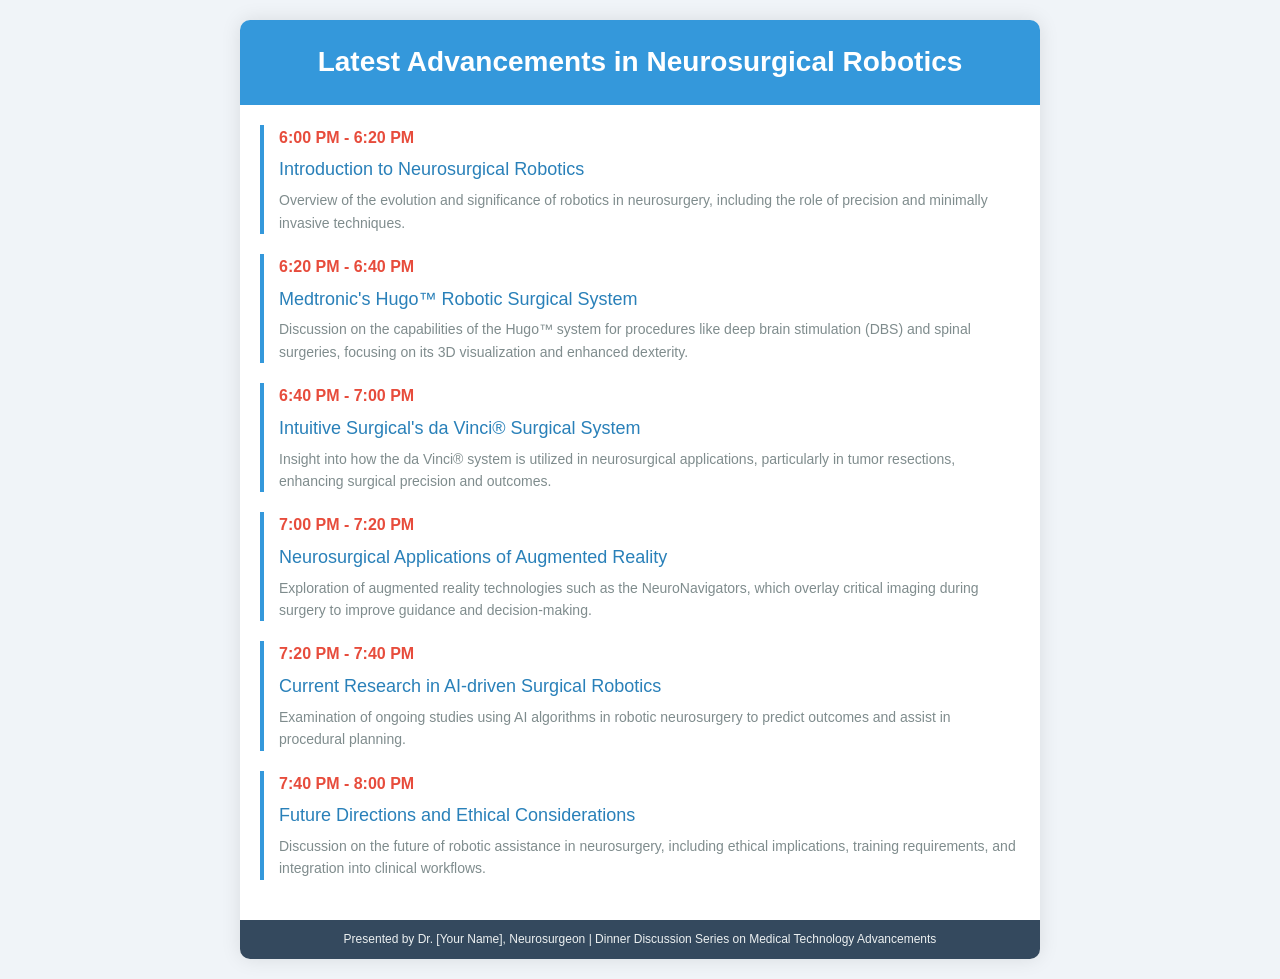What is the first topic discussed? The first topic in the schedule is the introduction to neurosurgical robotics, as indicated in the document.
Answer: Introduction to Neurosurgical Robotics What time does the discussion on Medtronic's Hugo™ Robotic Surgical System start? The document states that Medtronic's Hugo™ Robotic Surgical System discussion starts at 6:20 PM.
Answer: 6:20 PM Which robotic system is mentioned for tumor resections? The schedule highlights that the da Vinci® Surgical System is utilized for tumor resections in neurosurgery.
Answer: da Vinci® Surgical System What technology overlays critical imaging during surgery? The document refers to augmented reality technologies such as NeuroNavigators, which overlay imaging.
Answer: NeuroNavigators What is the focus of the discussion on current research? The document explains that the current research focuses on AI-driven surgical robotics and their role in predicting outcomes.
Answer: AI-driven Surgical Robotics What is the last topic discussed in the schedule? The final topic outlined in the document is about future directions and ethical considerations in robotic assistance.
Answer: Future Directions and Ethical Considerations 